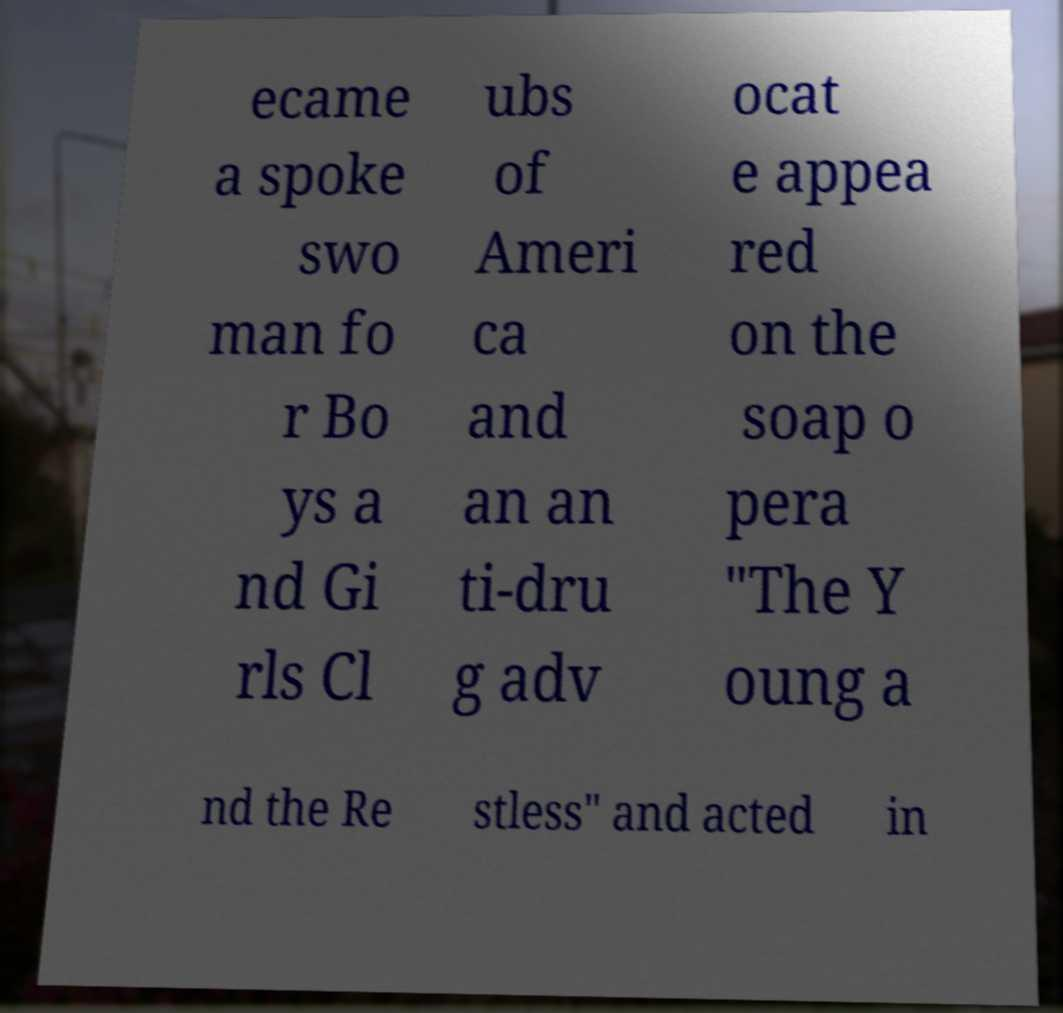Could you assist in decoding the text presented in this image and type it out clearly? ecame a spoke swo man fo r Bo ys a nd Gi rls Cl ubs of Ameri ca and an an ti-dru g adv ocat e appea red on the soap o pera "The Y oung a nd the Re stless" and acted in 